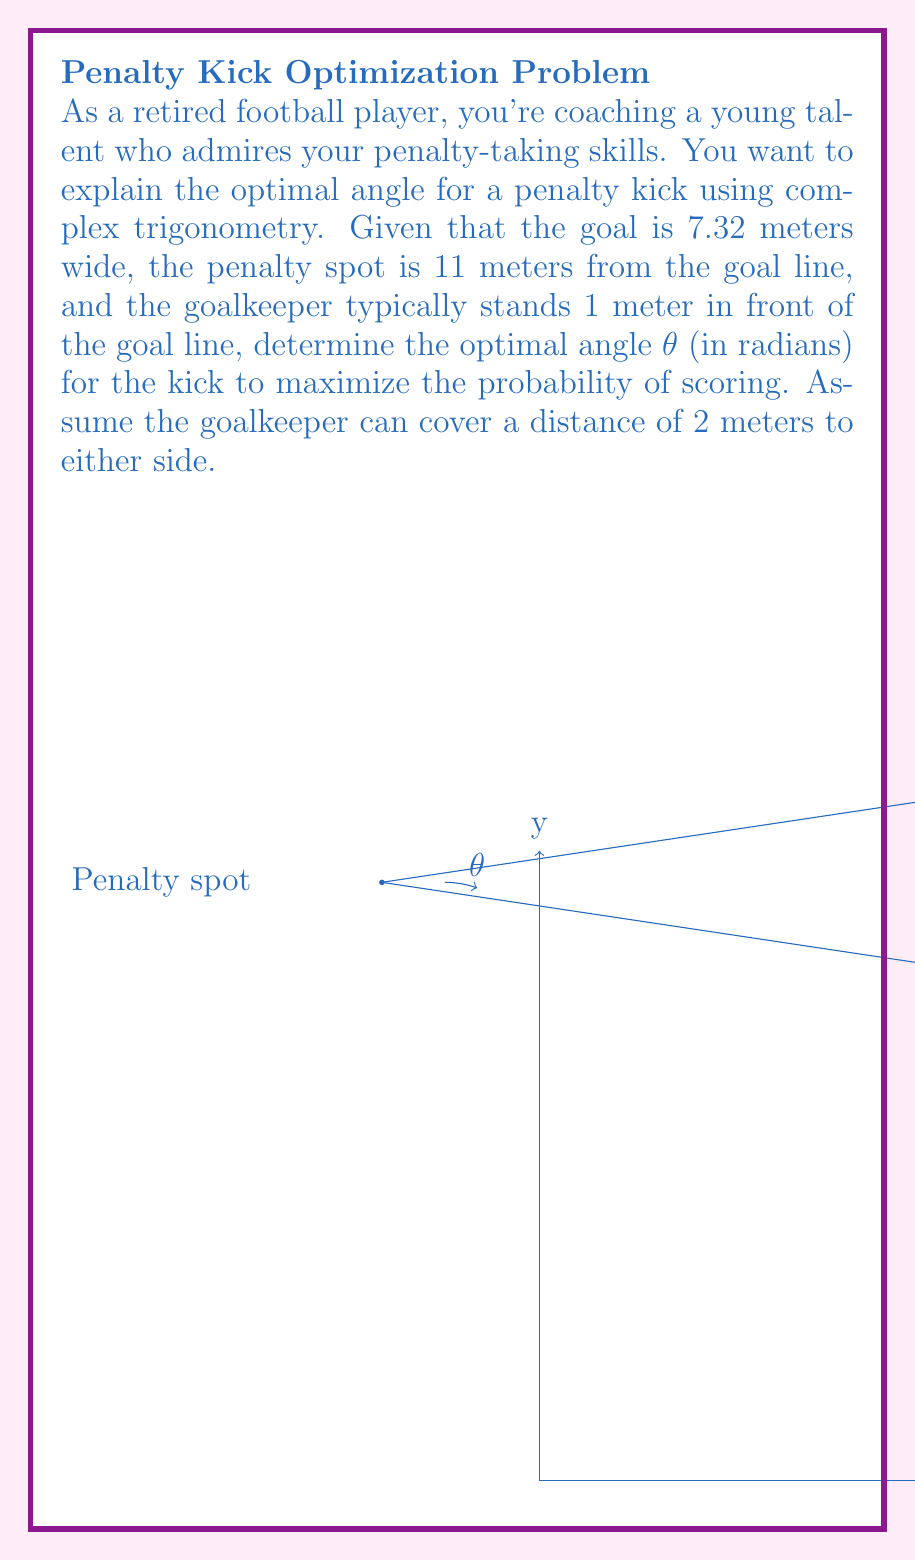Provide a solution to this math problem. Let's approach this step-by-step using complex trigonometry:

1) First, we need to set up our complex plane. Let's place the origin at the center of the goal line, with the positive real axis extending towards the right side of the goal.

2) The penalty spot is located at $z = -11i$ in this complex plane.

3) The edges of the area the goalkeeper can cover are at $z_1 = 1 + 3.66i$ and $z_2 = 1 - 3.66i$.

4) The optimal angle will bisect the angle between these two points as seen from the penalty spot. We can find this using the argument of complex numbers.

5) Let's calculate the complex numbers representing the vectors from the penalty spot to each edge:

   $v_1 = (1 + 3.66i) - (-11i) = 1 + 14.66i$
   $v_2 = (1 - 3.66i) - (-11i) = 1 + 7.34i$

6) The arguments of these vectors are:

   $\arg(v_1) = \arctan(\frac{14.66}{1}) = 1.5052$ radians
   $\arg(v_2) = \arctan(\frac{7.34}{1}) = 1.4348$ radians

7) The optimal angle θ will be the average of these two arguments:

   $θ = \frac{1.5052 + 1.4348}{2} = 1.47$ radians

8) We can verify this using the complex exponential form:

   $e^{iθ} = \cos θ + i \sin θ$

   Substituting our θ value should give us a vector that bisects the two edges.
Answer: $θ = 1.47$ radians 